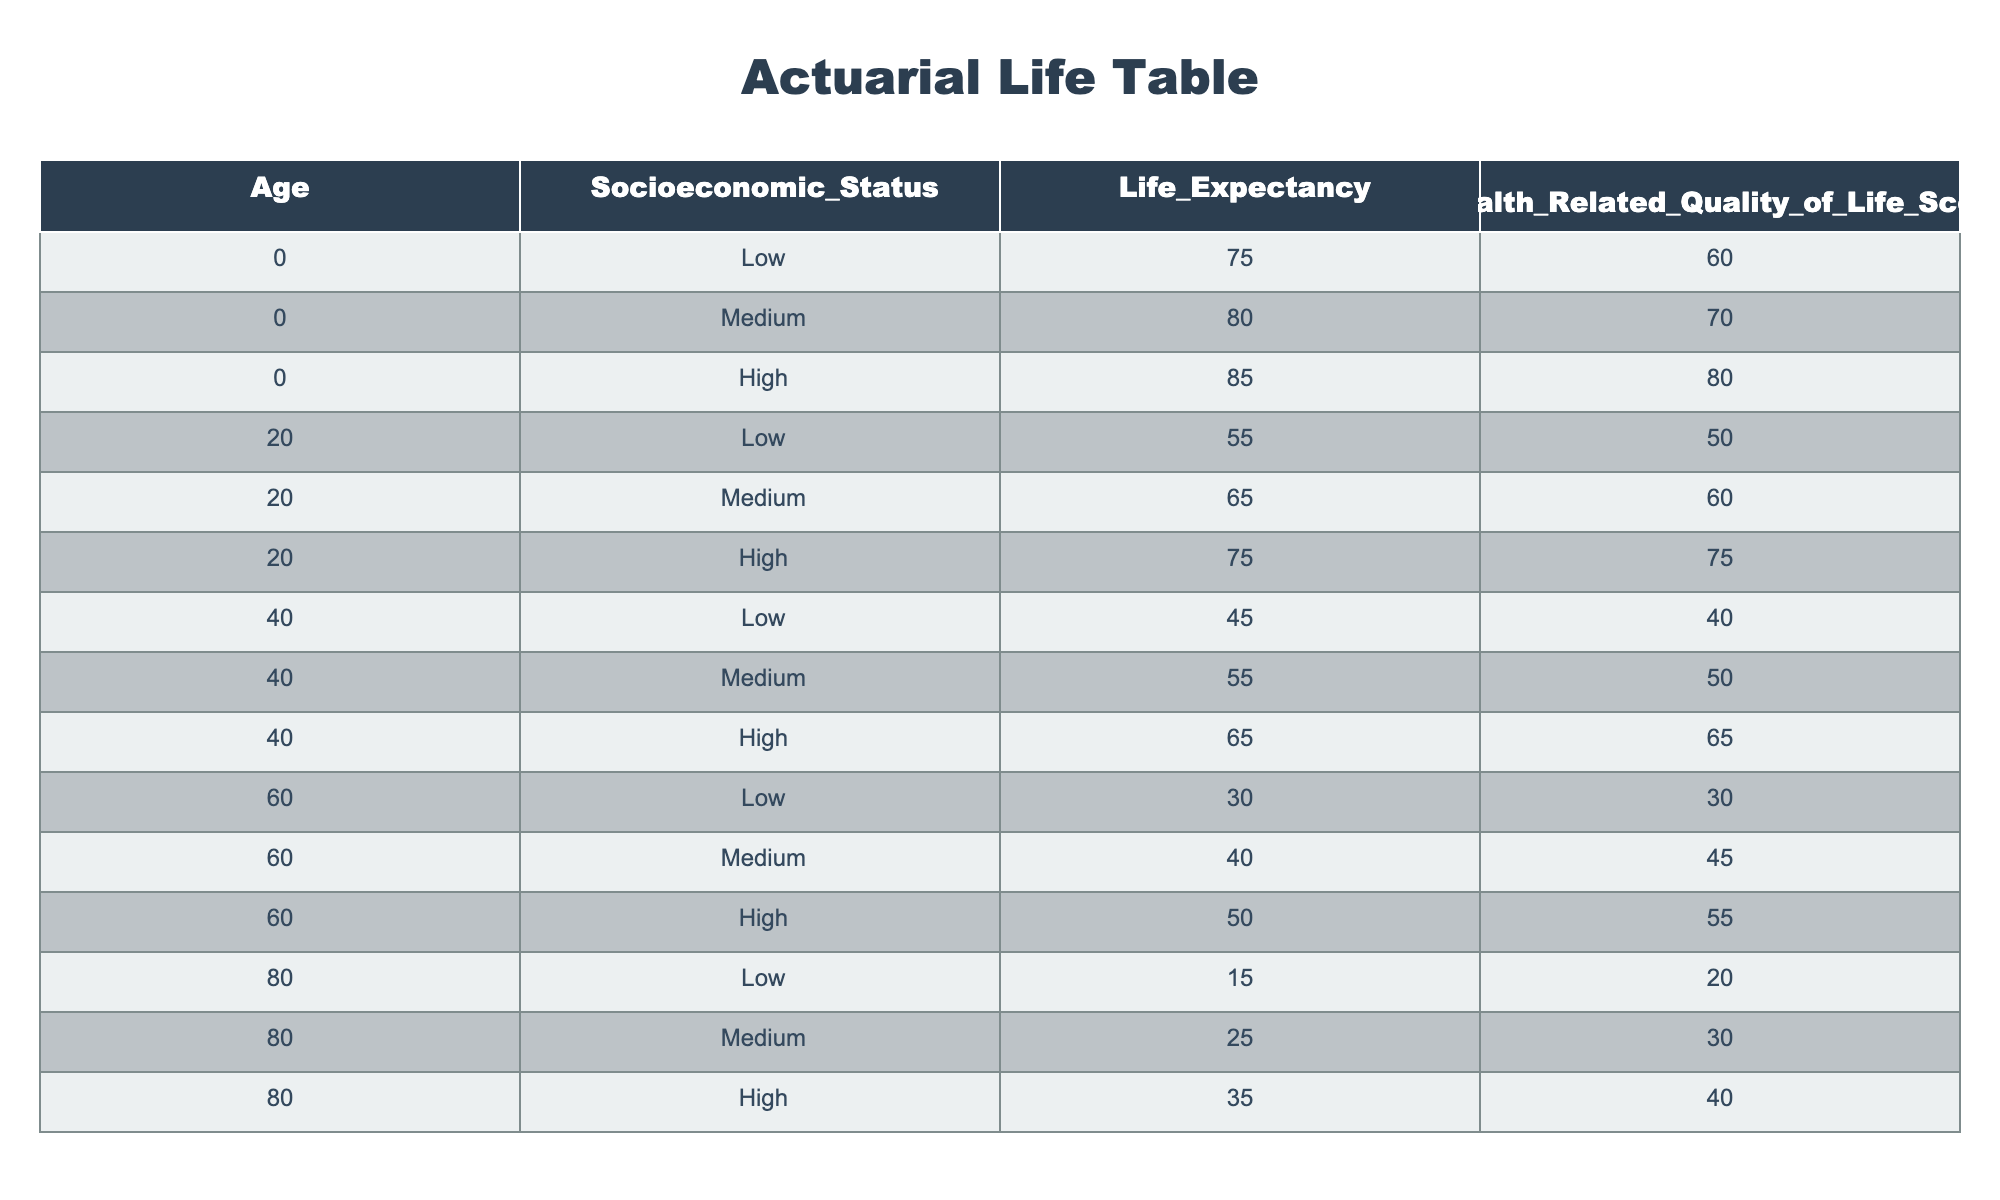What is the life expectancy for individuals aged 0 with a high socioeconomic status? According to the table, for individuals aged 0 with a high socioeconomic status, the life expectancy is 85 years.
Answer: 85 What is the health-related quality of life score for individuals aged 60 with a medium socioeconomic status? From the table, the score for this group is 45.
Answer: 45 Is it true that individuals aged 80 with medium socioeconomic status have a higher life expectancy than those aged 60 with low socioeconomic status? Yes, individuals aged 80 with medium socioeconomic status have a life expectancy of 25 years, while those aged 60 with low socioeconomic status have a life expectancy of 30 years.
Answer: Yes What is the difference in health-related quality of life scores between individuals aged 40 with high and low socioeconomic statuses? The health-related quality of life score for individuals aged 40 with high socioeconomic status is 65, and for those with low socioeconomic status is 40. The difference is 65 - 40 = 25.
Answer: 25 What is the average life expectancy for individuals aged 20 across all socioeconomic statuses? For individuals aged 20, the life expectancies are 55 (low), 65 (medium), and 75 (high). The average is (55 + 65 + 75) / 3 = 65.
Answer: 65 What is the overall trend in life expectancy as socioeconomic status increases for individuals aged 0? The life expectancy increases with socioeconomic status, from 75 (low) to 80 (medium) to 85 (high).
Answer: Increases Does the health-related quality of life score decline for individuals as they age from 0 to 80 in the low socioeconomic group? Yes, the score decreases from 60 (age 0) to 50 (age 20) to 40 (age 40) to 30 (age 60) to 20 (age 80).
Answer: Yes What is the total life expectancy for all age groups combined with high socioeconomic status? The life expectancies for high socioeconomic status are 85 (age 0), 75 (age 20), 65 (age 40), 50 (age 60), and 35 (age 80). The total is 85 + 75 + 65 + 50 + 35 = 310.
Answer: 310 What is the health-related quality of life score for individuals aged 20 with low socioeconomic status? According to the table, this score is 50.
Answer: 50 